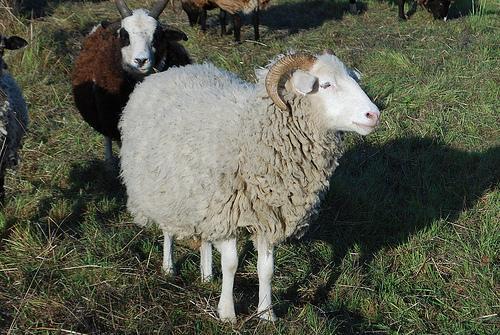How many sheep are in the photo?
Give a very brief answer. 2. 